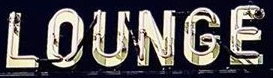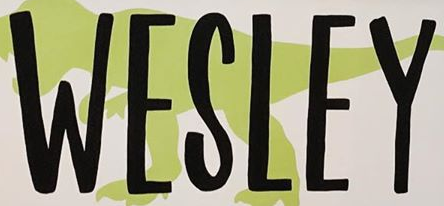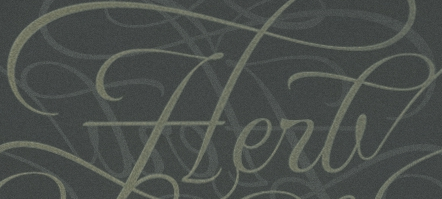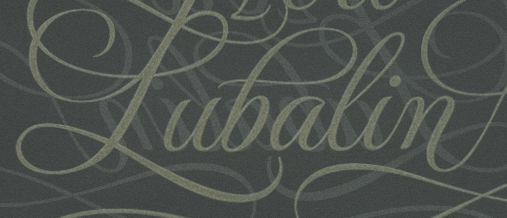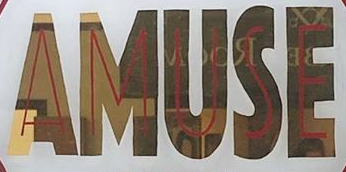Read the text content from these images in order, separated by a semicolon. LOUNGE; WESLEY; Herb; Pubalin; AMUSE 